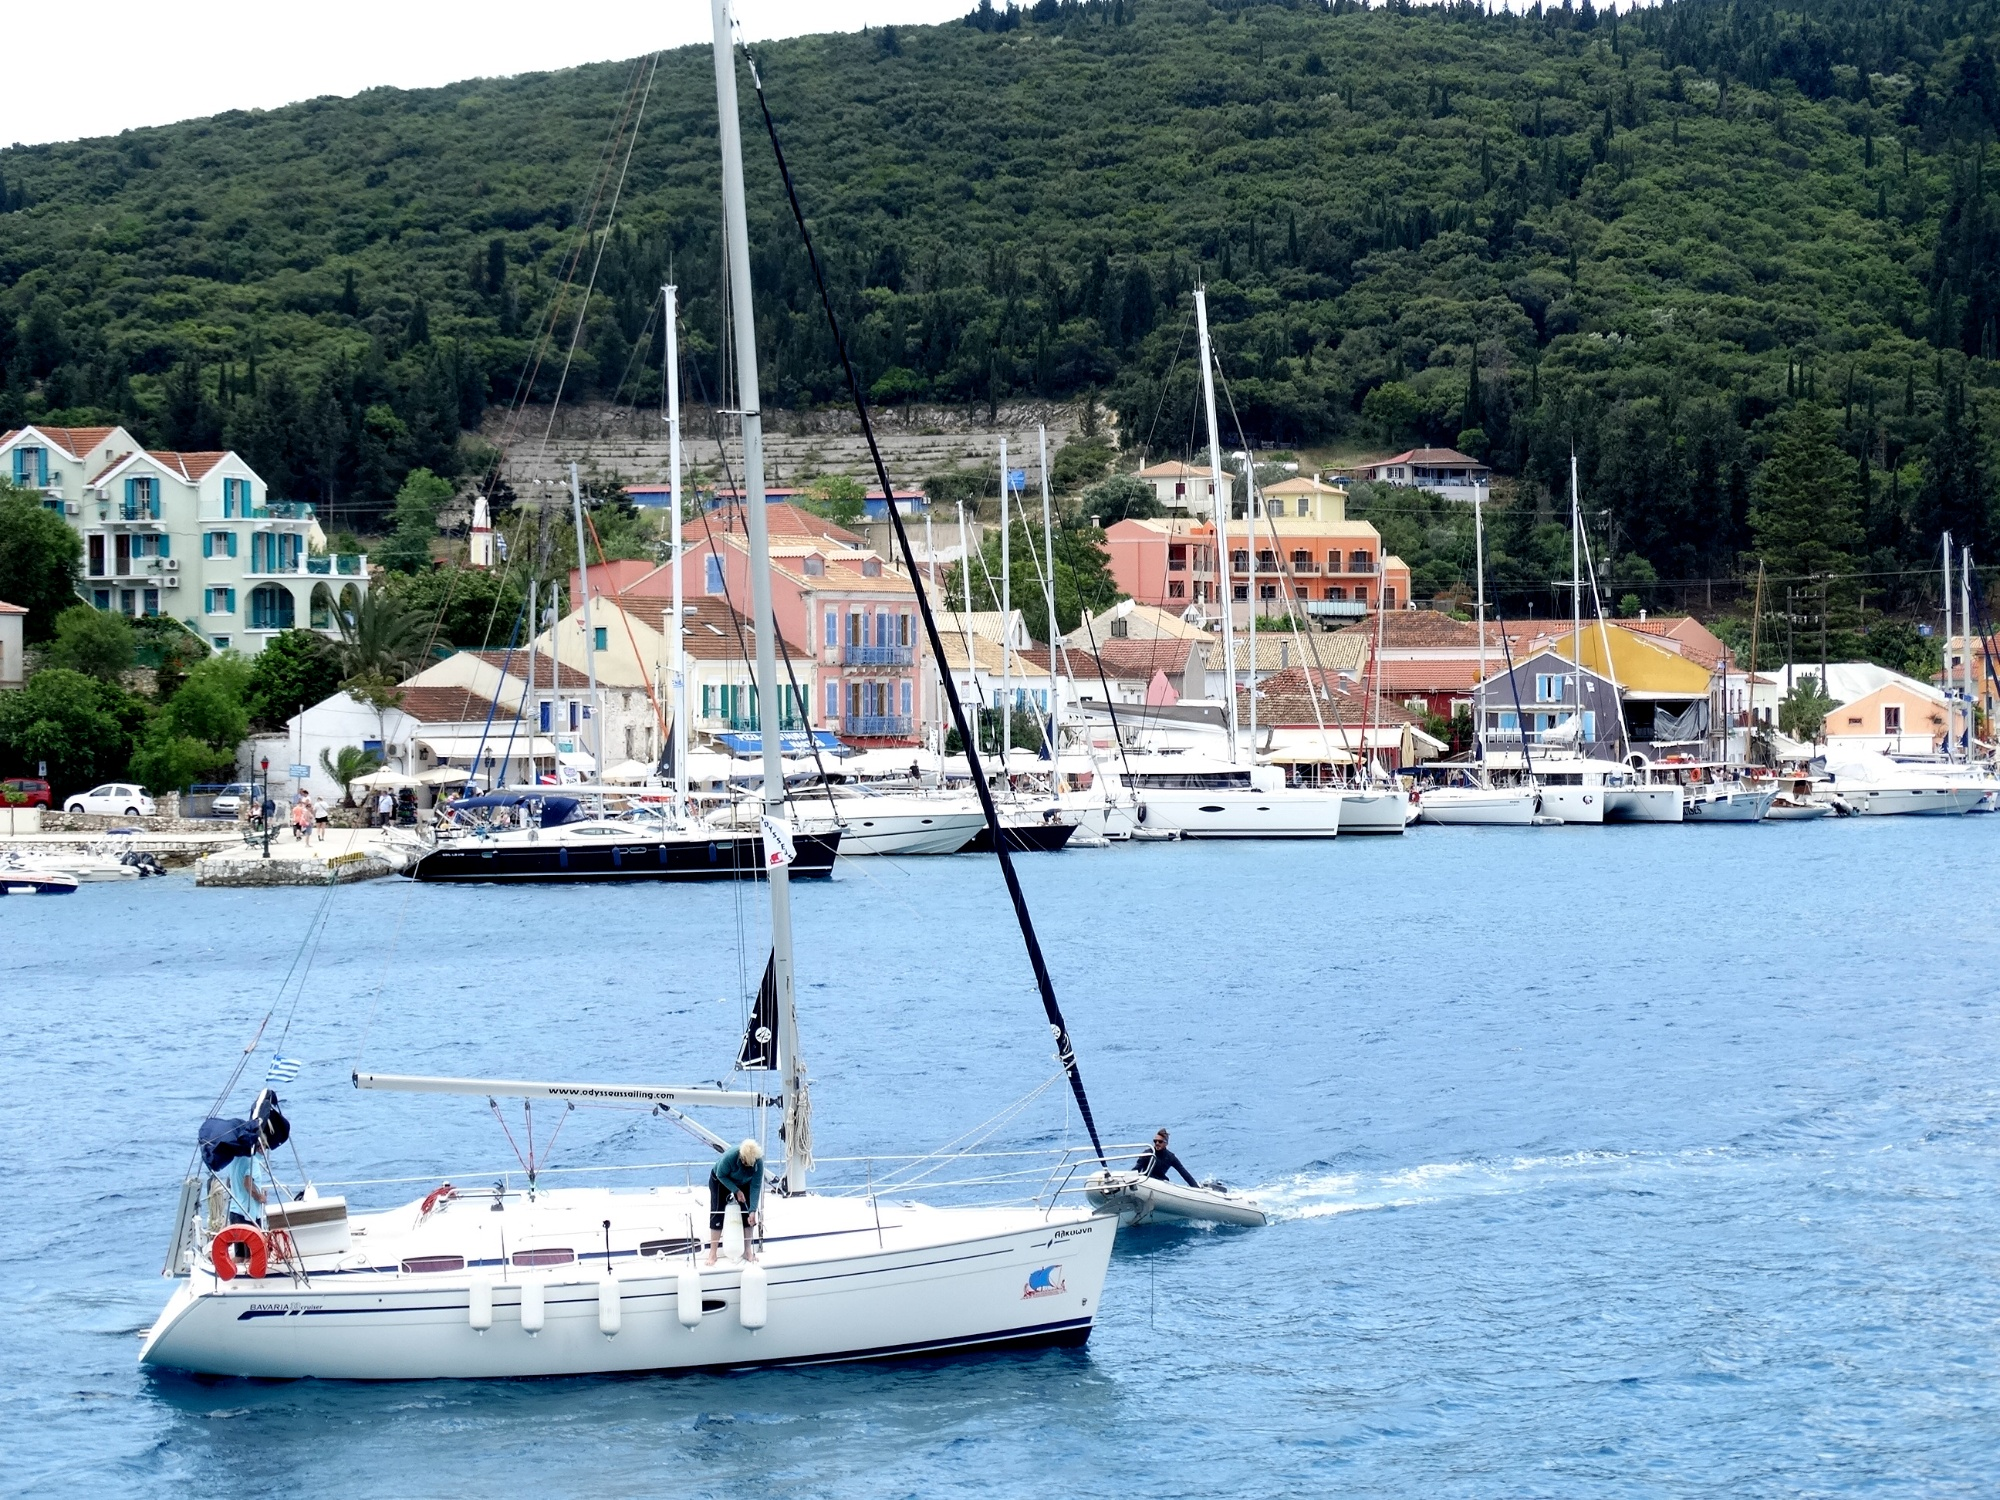Can you speculate on the weather conditions based on this image? The overcast sky suggests a day where sunlight is diffuse, creating soft shadows and preventing the harsh glare of direct sunlight. These conditions are ideal for photography, as they provide even lighting. The calm sea and absence of rain suggest stable weather, likely comfortable for outdoor activities. However, sailboats generally prefer a bit of wind, and the absence of visible sails raised on the boats in the harbor could mean the wind might be too light for sailing at this moment. 